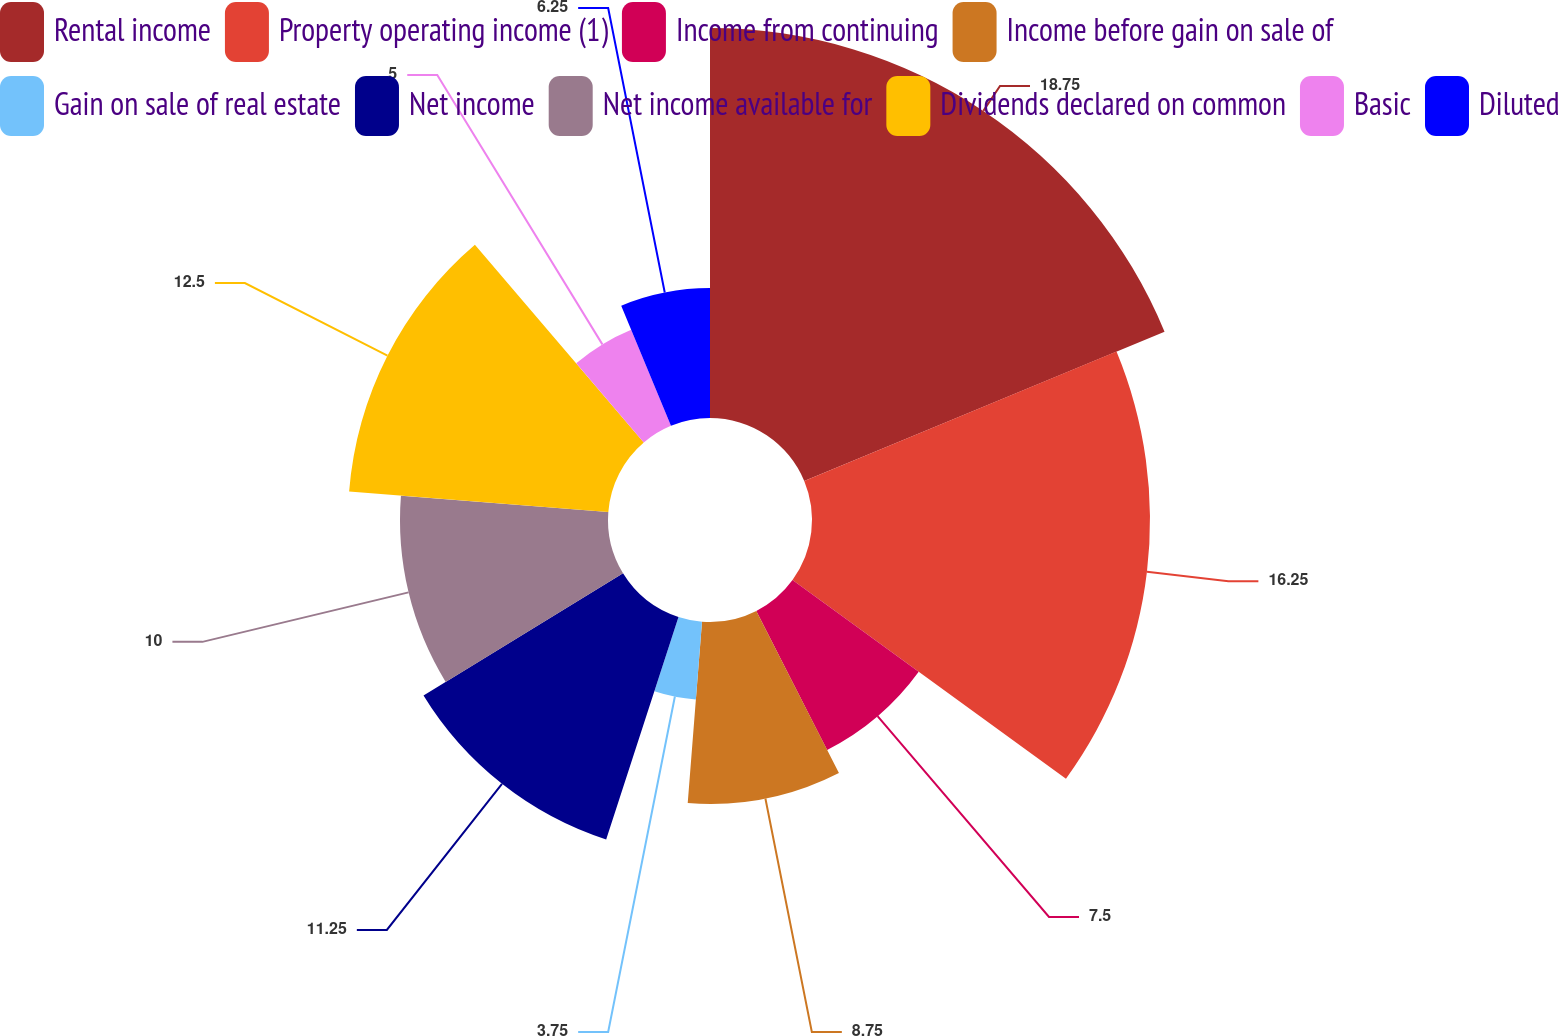Convert chart to OTSL. <chart><loc_0><loc_0><loc_500><loc_500><pie_chart><fcel>Rental income<fcel>Property operating income (1)<fcel>Income from continuing<fcel>Income before gain on sale of<fcel>Gain on sale of real estate<fcel>Net income<fcel>Net income available for<fcel>Dividends declared on common<fcel>Basic<fcel>Diluted<nl><fcel>18.75%<fcel>16.25%<fcel>7.5%<fcel>8.75%<fcel>3.75%<fcel>11.25%<fcel>10.0%<fcel>12.5%<fcel>5.0%<fcel>6.25%<nl></chart> 